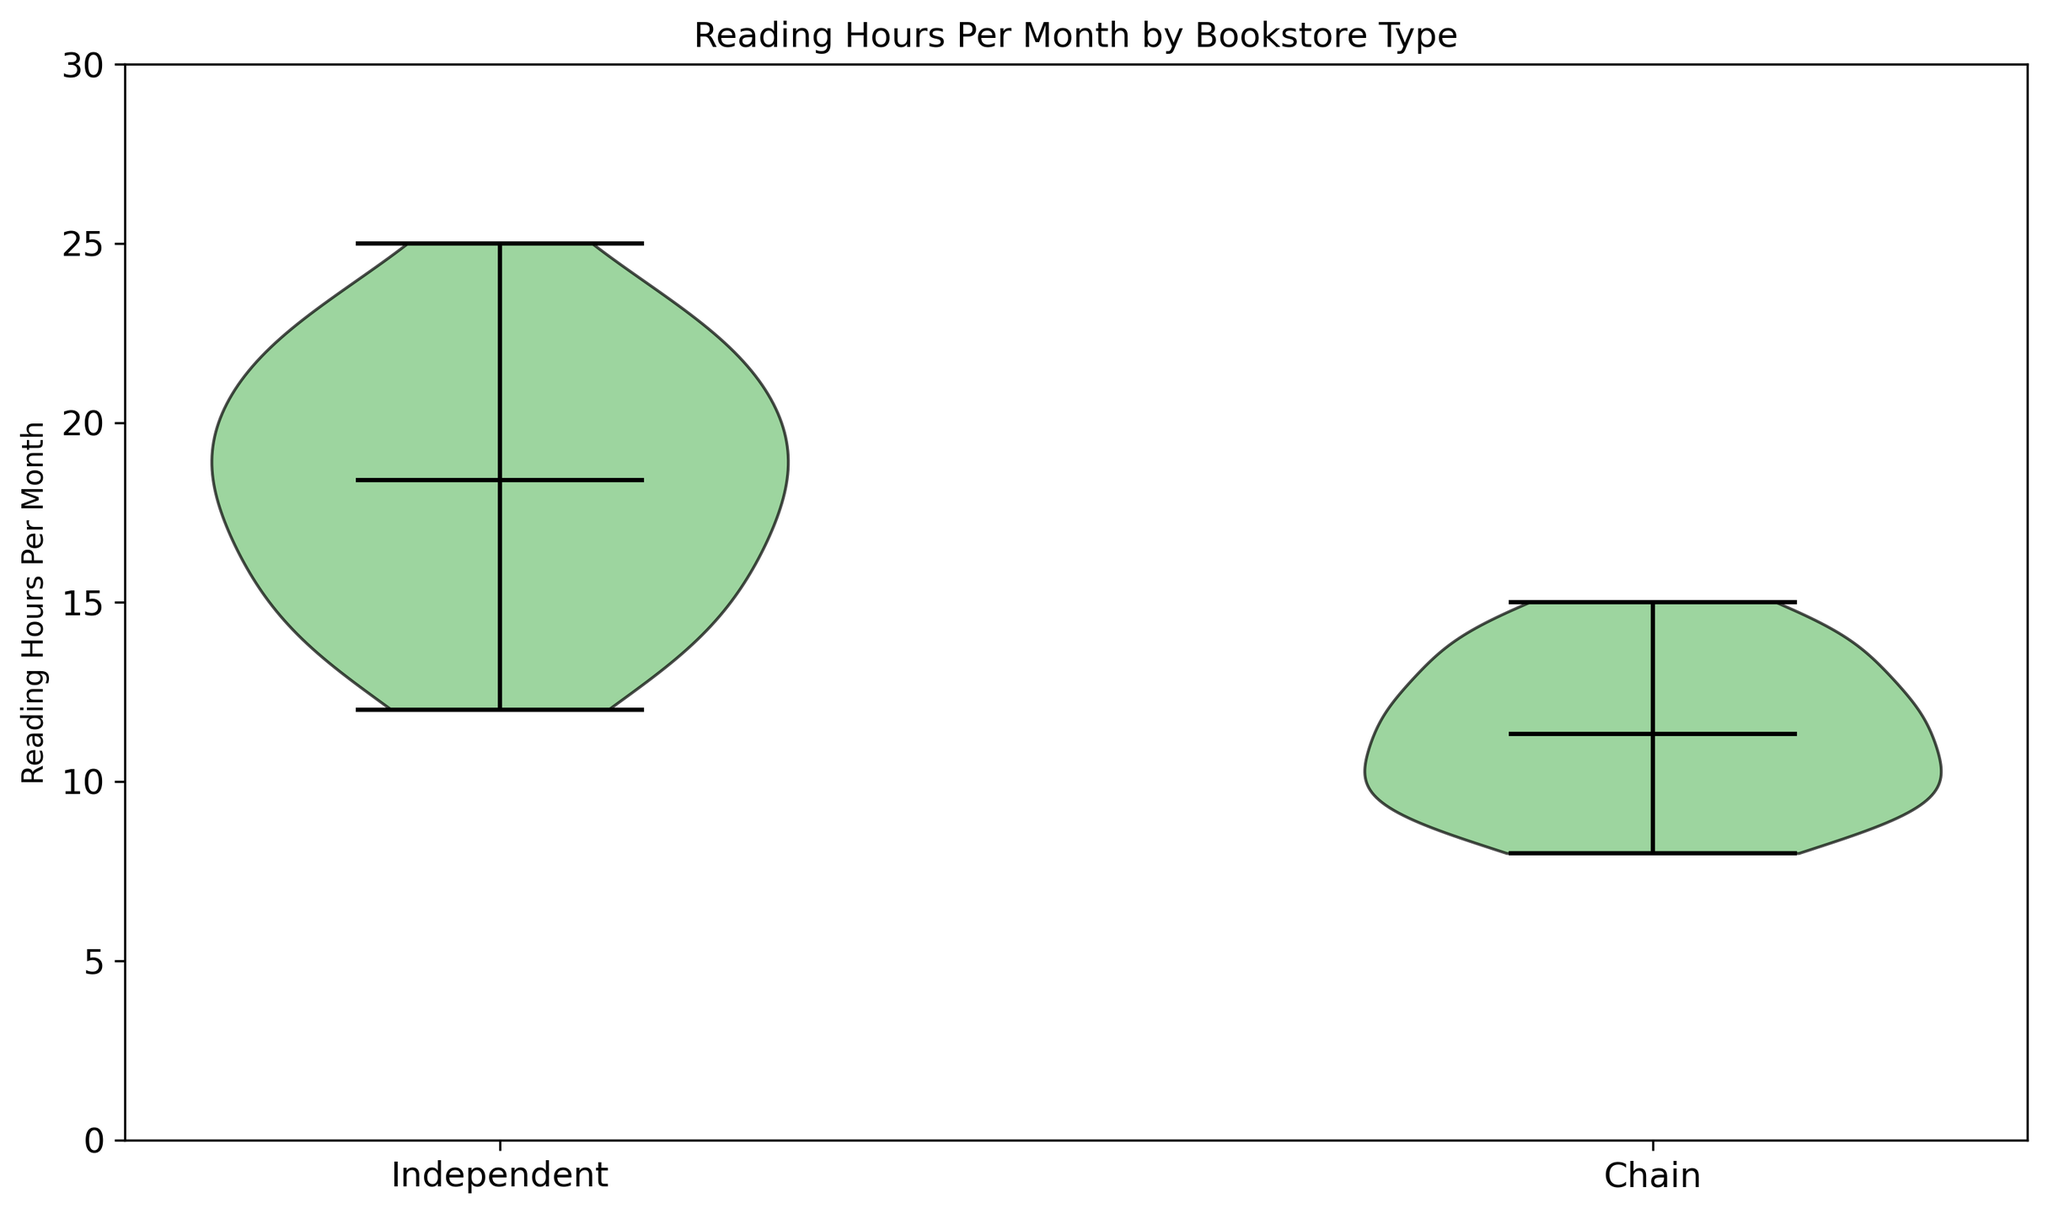What's the most common range of reading hours for customers of independent bookstores? Looking at the shape of the violin plot for independent bookstores, the widest part of the plot indicates the most common range. For independent bookstores, this widest part is around the 16-22 hours per month range.
Answer: 16-22 hours per month Which type of bookstore has customers with a higher average reading hours per month? The mean values are shown as dots inside the violins. The mean reading hours for independent bookstores is higher compared to chain bookstores.
Answer: Independent bookstores What's the difference between the median reading hours of customers for independent and chain bookstores? The median is the point where half the data is below and half is above. For independent bookstores, the median is around the middle of the wide part of the violin, approximately 19 hours. The median for chain bookstores is around the middle part of the violin, approximately 11 hours. The difference is 19 - 11 = 8 hours.
Answer: 8 hours Which bookstore type displays a wider distribution of customer reading hours? The spread of the violin plot indicates distribution width. Independent bookstores have a wider spread, suggesting more variability in reading hours.
Answer: Independent bookstores What is the approximate maximum reading hours per month observed for customers of chain bookstores? Looking at the top end of the violin plot for chain bookstores, the maximum observed reading hours per month is around 15 hours.
Answer: 15 hours Visualize the mean reading hours of customers for both bookstore types on the plot. On the violin plot, the mean is marked by a small black dot inside each violin. It shows the central value of reading hours for each bookstore type. The mean for independent bookstores is approximately in the 18-19 hours per month range, and for chain bookstores is around 10-11 hours per month.
Answer: 18-19 hours (Independent), 10-11 hours (Chain) Does any bookstore type's violin plot have multiple peaks, indicating multiple modes? The violin plot for independent bookstores has multiple peaks, suggesting that there are different common ranges of reading hours among their customers, indicating multiple modes.
Answer: Independent bookstores Which type of bookstore has customers with the smallest reading hours per month? The bottom end of the violin plot for chain bookstores shows the smallest observed reading hours per month is around 8 hours.
Answer: Chain bookstores Are the reading habits more uniform amongst customers of chain bookstores as compared to independent bookstores? The distribution for chain bookstores is narrower and more concentrated around a central value, indicating more uniform reading habits.
Answer: Yes Is there any overlap in the range of reading hours between customers of independent and chain bookstores? The violin plots of both bookstore types overlap in the range of approximately 12-15 hours per month, indicating some customers from both types of bookstores read within this range.
Answer: Yes 